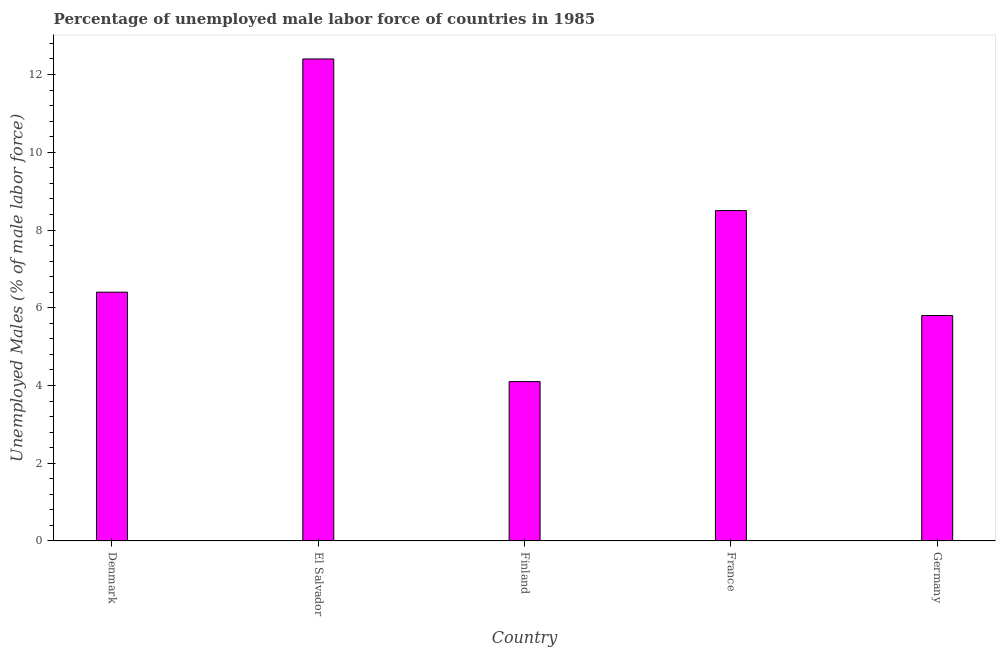Does the graph contain any zero values?
Provide a short and direct response. No. What is the title of the graph?
Provide a succinct answer. Percentage of unemployed male labor force of countries in 1985. What is the label or title of the X-axis?
Make the answer very short. Country. What is the label or title of the Y-axis?
Give a very brief answer. Unemployed Males (% of male labor force). What is the total unemployed male labour force in Denmark?
Provide a short and direct response. 6.4. Across all countries, what is the maximum total unemployed male labour force?
Keep it short and to the point. 12.4. Across all countries, what is the minimum total unemployed male labour force?
Ensure brevity in your answer.  4.1. In which country was the total unemployed male labour force maximum?
Your response must be concise. El Salvador. What is the sum of the total unemployed male labour force?
Your answer should be very brief. 37.2. What is the difference between the total unemployed male labour force in Denmark and Finland?
Keep it short and to the point. 2.3. What is the average total unemployed male labour force per country?
Ensure brevity in your answer.  7.44. What is the median total unemployed male labour force?
Your response must be concise. 6.4. What is the ratio of the total unemployed male labour force in Denmark to that in El Salvador?
Ensure brevity in your answer.  0.52. Is the difference between the total unemployed male labour force in Finland and France greater than the difference between any two countries?
Your response must be concise. No. What is the difference between the highest and the second highest total unemployed male labour force?
Give a very brief answer. 3.9. In how many countries, is the total unemployed male labour force greater than the average total unemployed male labour force taken over all countries?
Ensure brevity in your answer.  2. How many bars are there?
Your answer should be very brief. 5. Are all the bars in the graph horizontal?
Your answer should be compact. No. How many countries are there in the graph?
Your answer should be compact. 5. What is the Unemployed Males (% of male labor force) of Denmark?
Keep it short and to the point. 6.4. What is the Unemployed Males (% of male labor force) of El Salvador?
Ensure brevity in your answer.  12.4. What is the Unemployed Males (% of male labor force) in Finland?
Your answer should be very brief. 4.1. What is the Unemployed Males (% of male labor force) in France?
Make the answer very short. 8.5. What is the Unemployed Males (% of male labor force) of Germany?
Your answer should be compact. 5.8. What is the difference between the Unemployed Males (% of male labor force) in Denmark and El Salvador?
Offer a very short reply. -6. What is the difference between the Unemployed Males (% of male labor force) in Denmark and France?
Your answer should be compact. -2.1. What is the difference between the Unemployed Males (% of male labor force) in Denmark and Germany?
Give a very brief answer. 0.6. What is the difference between the Unemployed Males (% of male labor force) in El Salvador and France?
Keep it short and to the point. 3.9. What is the difference between the Unemployed Males (% of male labor force) in Finland and France?
Offer a terse response. -4.4. What is the difference between the Unemployed Males (% of male labor force) in Finland and Germany?
Offer a terse response. -1.7. What is the ratio of the Unemployed Males (% of male labor force) in Denmark to that in El Salvador?
Provide a succinct answer. 0.52. What is the ratio of the Unemployed Males (% of male labor force) in Denmark to that in Finland?
Provide a succinct answer. 1.56. What is the ratio of the Unemployed Males (% of male labor force) in Denmark to that in France?
Offer a terse response. 0.75. What is the ratio of the Unemployed Males (% of male labor force) in Denmark to that in Germany?
Offer a terse response. 1.1. What is the ratio of the Unemployed Males (% of male labor force) in El Salvador to that in Finland?
Offer a very short reply. 3.02. What is the ratio of the Unemployed Males (% of male labor force) in El Salvador to that in France?
Give a very brief answer. 1.46. What is the ratio of the Unemployed Males (% of male labor force) in El Salvador to that in Germany?
Your answer should be very brief. 2.14. What is the ratio of the Unemployed Males (% of male labor force) in Finland to that in France?
Ensure brevity in your answer.  0.48. What is the ratio of the Unemployed Males (% of male labor force) in Finland to that in Germany?
Your answer should be compact. 0.71. What is the ratio of the Unemployed Males (% of male labor force) in France to that in Germany?
Provide a succinct answer. 1.47. 